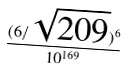<formula> <loc_0><loc_0><loc_500><loc_500>\frac { ( 6 / \sqrt { 2 0 9 } ) ^ { 6 } } { 1 0 ^ { 1 6 9 } }</formula> 